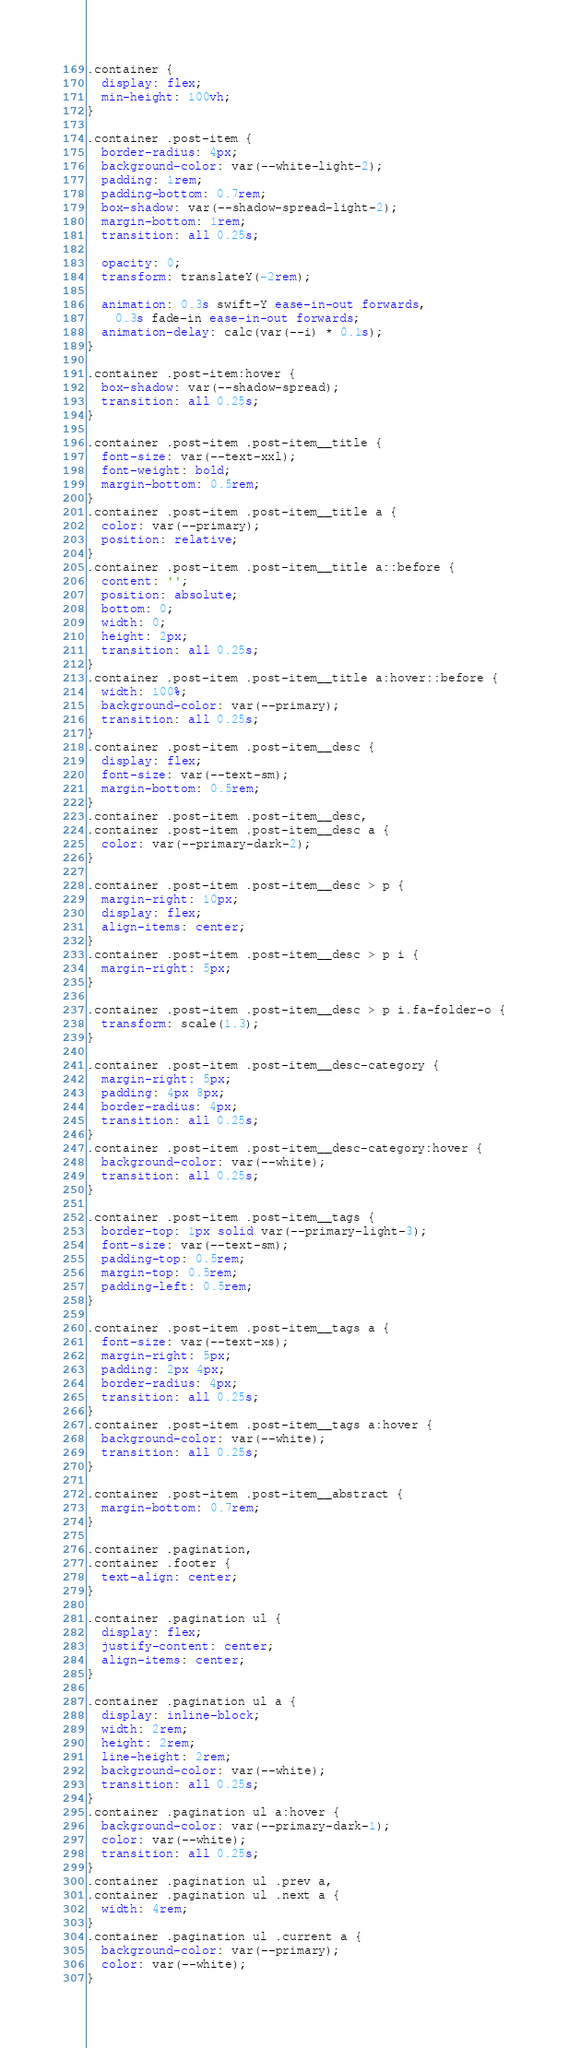<code> <loc_0><loc_0><loc_500><loc_500><_CSS_>.container {
  display: flex;
  min-height: 100vh;
}

.container .post-item {
  border-radius: 4px;
  background-color: var(--white-light-2);
  padding: 1rem;
  padding-bottom: 0.7rem;
  box-shadow: var(--shadow-spread-light-2);
  margin-bottom: 1rem;
  transition: all 0.25s;

  opacity: 0;
  transform: translateY(-2rem);

  animation: 0.3s swift-Y ease-in-out forwards,
    0.3s fade-in ease-in-out forwards;
  animation-delay: calc(var(--i) * 0.1s);
}

.container .post-item:hover {
  box-shadow: var(--shadow-spread);
  transition: all 0.25s;
}

.container .post-item .post-item__title {
  font-size: var(--text-xxl);
  font-weight: bold;
  margin-bottom: 0.5rem;
}
.container .post-item .post-item__title a {
  color: var(--primary);
  position: relative;
}
.container .post-item .post-item__title a::before {
  content: '';
  position: absolute;
  bottom: 0;
  width: 0;
  height: 2px;
  transition: all 0.25s;
}
.container .post-item .post-item__title a:hover::before {
  width: 100%;
  background-color: var(--primary);
  transition: all 0.25s;
}
.container .post-item .post-item__desc {
  display: flex;
  font-size: var(--text-sm);
  margin-bottom: 0.5rem;
}
.container .post-item .post-item__desc,
.container .post-item .post-item__desc a {
  color: var(--primary-dark-2);
}

.container .post-item .post-item__desc > p {
  margin-right: 10px;
  display: flex;
  align-items: center;
}
.container .post-item .post-item__desc > p i {
  margin-right: 5px;
}

.container .post-item .post-item__desc > p i.fa-folder-o {
  transform: scale(1.3);
}

.container .post-item .post-item__desc-category {
  margin-right: 5px;
  padding: 4px 8px;
  border-radius: 4px;
  transition: all 0.25s;
}
.container .post-item .post-item__desc-category:hover {
  background-color: var(--white);
  transition: all 0.25s;
}

.container .post-item .post-item__tags {
  border-top: 1px solid var(--primary-light-3);
  font-size: var(--text-sm);
  padding-top: 0.5rem;
  margin-top: 0.5rem;
  padding-left: 0.5rem;
}

.container .post-item .post-item__tags a {
  font-size: var(--text-xs);
  margin-right: 5px;
  padding: 2px 4px;
  border-radius: 4px;
  transition: all 0.25s;
}
.container .post-item .post-item__tags a:hover {
  background-color: var(--white);
  transition: all 0.25s;
}

.container .post-item .post-item__abstract {
  margin-bottom: 0.7rem;
}

.container .pagination,
.container .footer {
  text-align: center;
}

.container .pagination ul {
  display: flex;
  justify-content: center;
  align-items: center;
}

.container .pagination ul a {
  display: inline-block;
  width: 2rem;
  height: 2rem;
  line-height: 2rem;
  background-color: var(--white);
  transition: all 0.25s;
}
.container .pagination ul a:hover {
  background-color: var(--primary-dark-1);
  color: var(--white);
  transition: all 0.25s;
}
.container .pagination ul .prev a,
.container .pagination ul .next a {
  width: 4rem;
}
.container .pagination ul .current a {
  background-color: var(--primary);
  color: var(--white);
}
</code> 